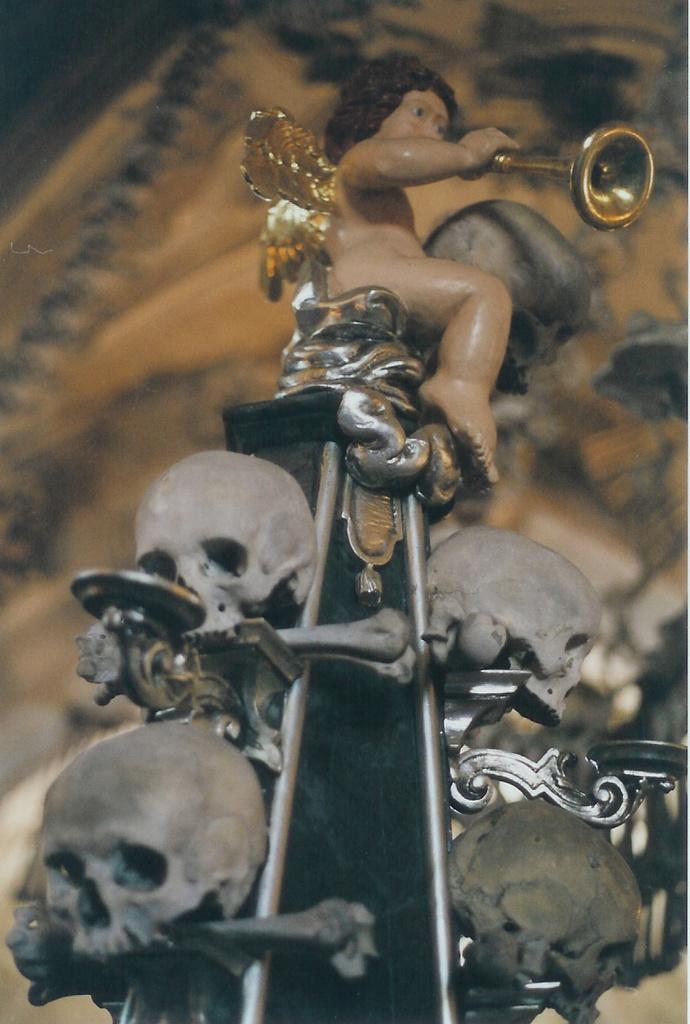What is the main subject in the image? There is a statue in the image. What is the statue sitting on? The statue is sitting on an object. What other objects can be seen in the image? There are skulls in the image. What is the color of the skulls? The skulls are white in color. What is the background color of the image? The background of the image is cream-colored. How does the statue taste in the image? The statue is not an edible object, so it cannot be tasted. 